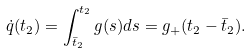<formula> <loc_0><loc_0><loc_500><loc_500>\dot { q } ( t _ { 2 } ) = \int _ { \bar { t } _ { 2 } } ^ { t _ { 2 } } g ( s ) d s = g _ { + } ( t _ { 2 } - \bar { t } _ { 2 } ) .</formula> 